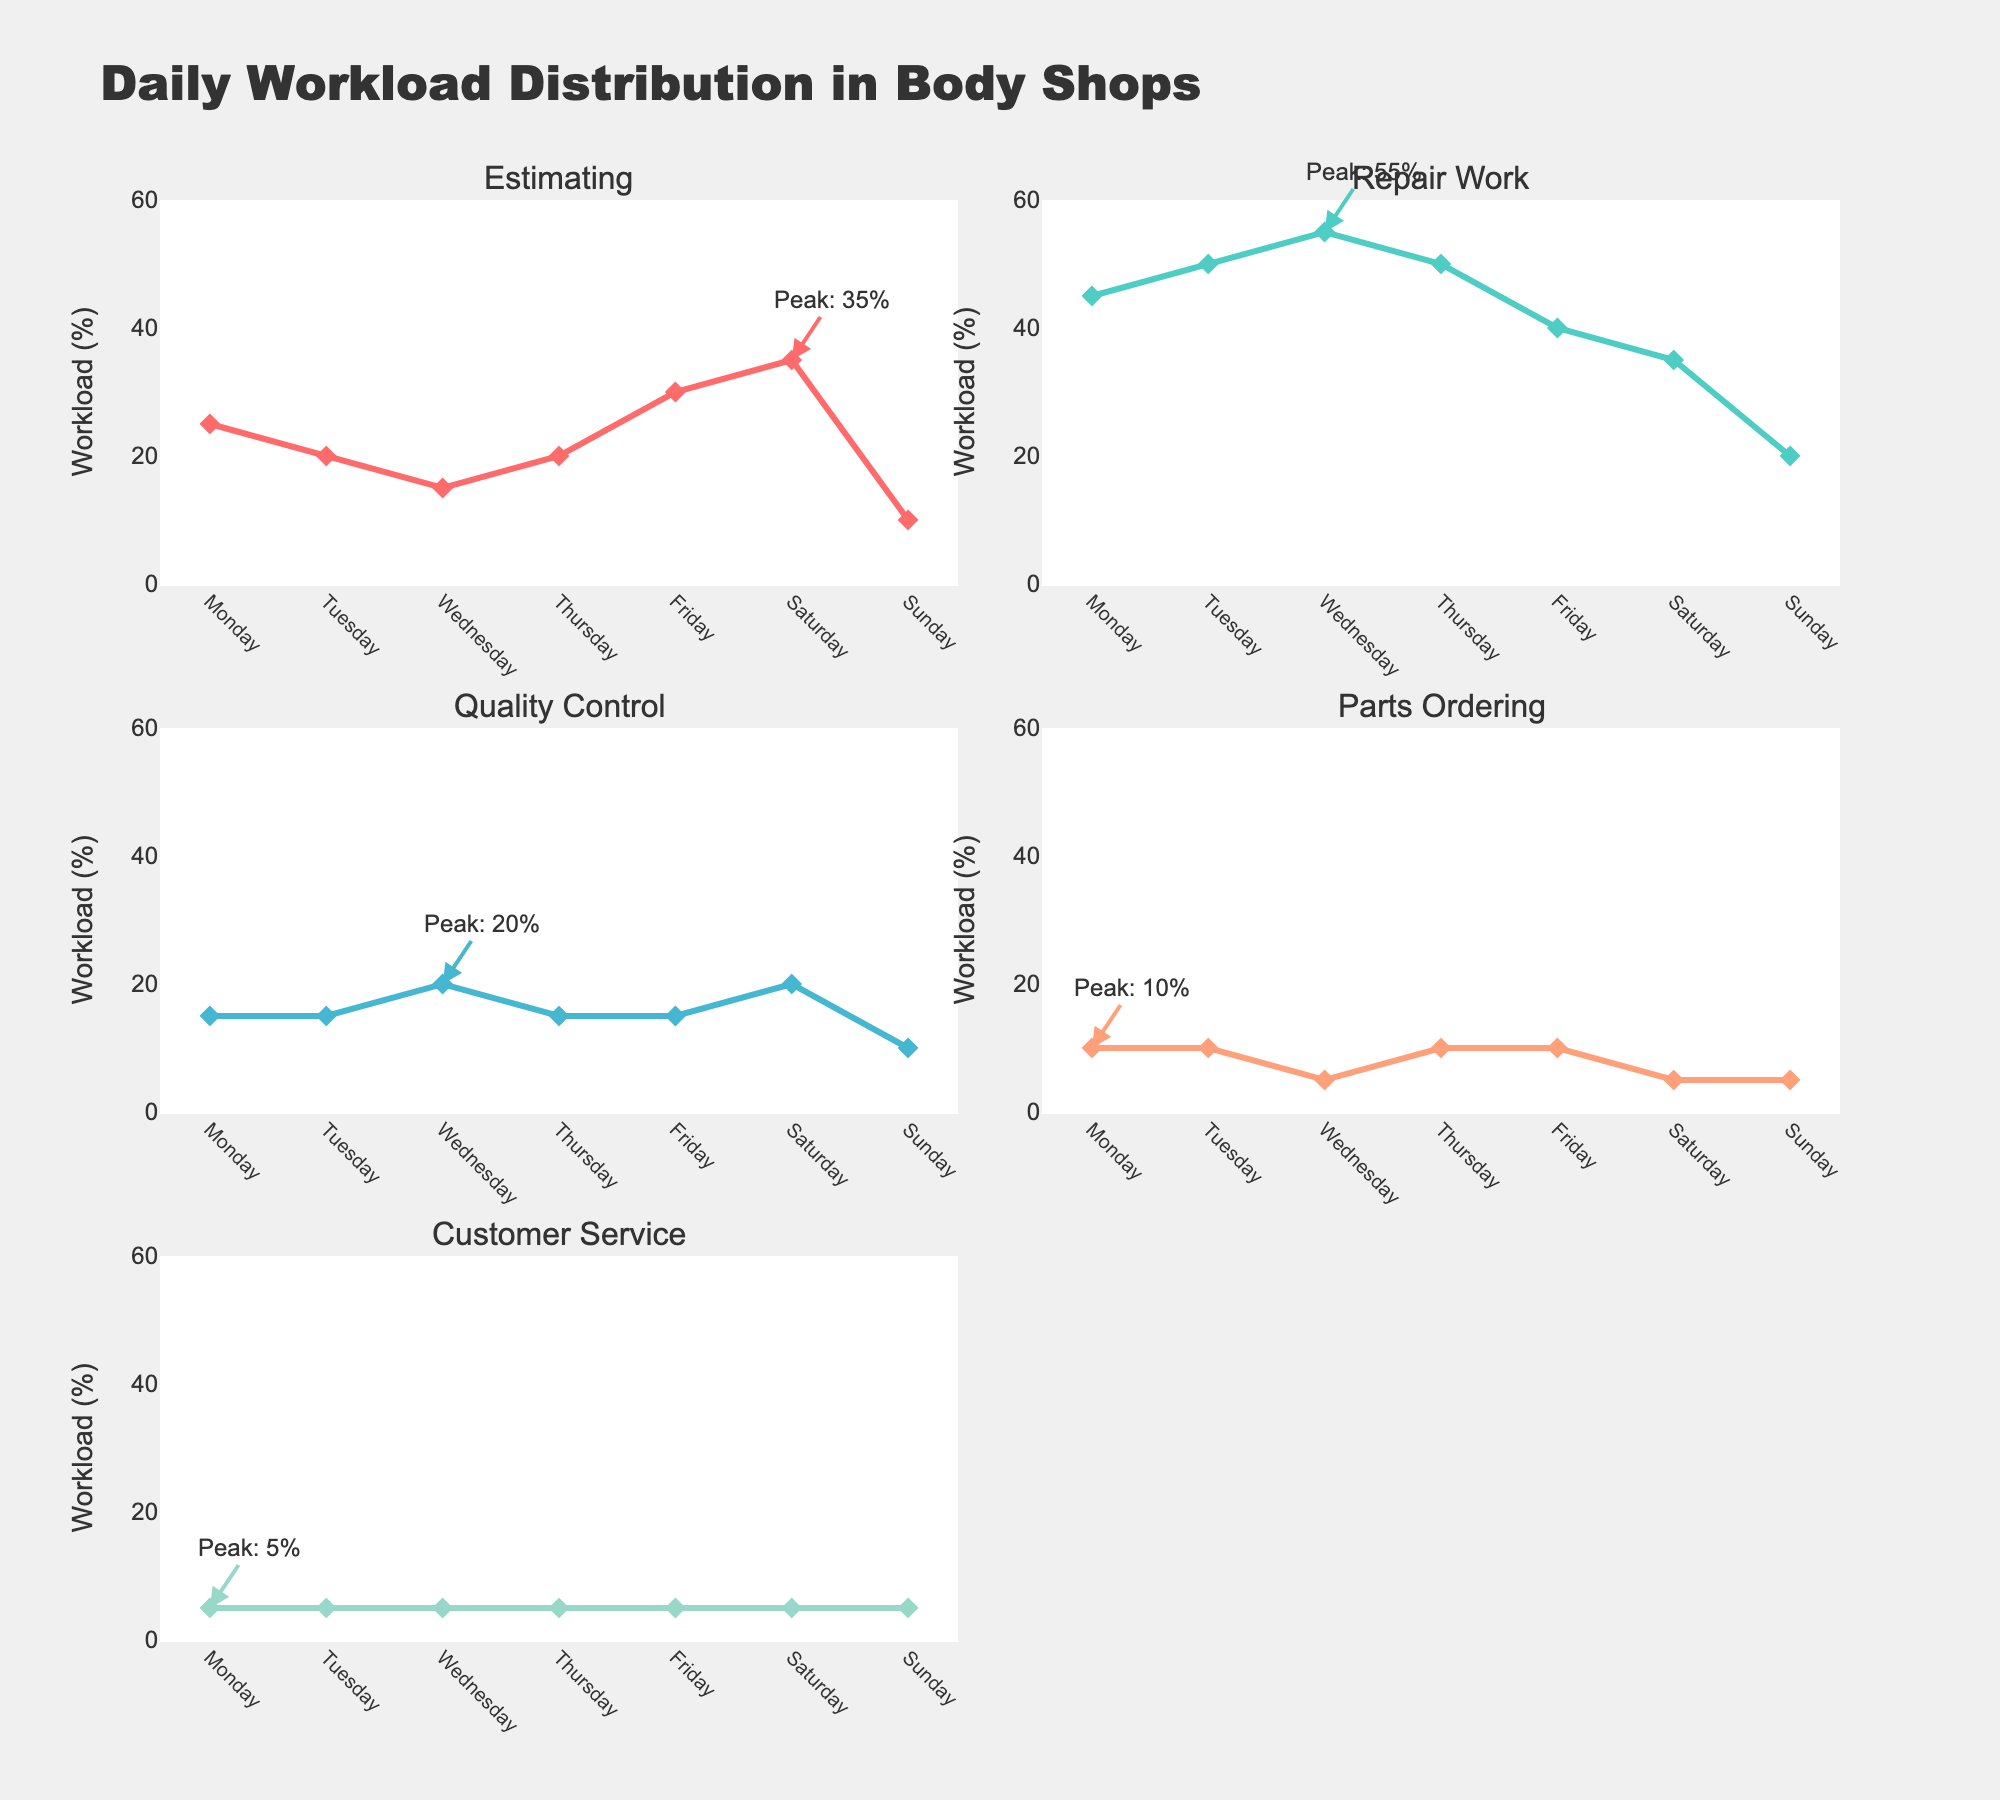Which task has the peak workload on Monday? The plot shows the peak workload for each task with annotations. For Monday, the highest peak annotation shows Repair Work with 45%.
Answer: Repair Work What is the average workload for Quality Control from Monday to Sunday? The Quality Control values for the week are 15, 15, 20, 15, 15, 20, 10. Adding these values gives 110. Dividing by 7 (number of days) results in an average of 110/7 ≈ 15.71.
Answer: ~15.71 Which day has the lowest workload for Estimating? Examining the Estimating subplot across the days, Sunday has the lowest workload with 10%.
Answer: Sunday Is the workload for Repair Work consistent throughout the week? Looking at the Repair Work subplot, the workload fluctuates between a minimum of 20% (Sunday) and a maximum of 55% (Wednesday), showing variability rather than consistency.
Answer: No How does Parts Ordering workload on Wednesday compare to that on Friday? From the Parts Ordering subplot, Wednesday has 5% and Friday also has 10%, making them equal.
Answer: Equal What is the total workload percentage for Customer Service over the week? Summing Customer Service percentages for each day: 5 + 5 + 5 + 5 + 5 + 5 + 5 = 35%.
Answer: 35% On which day does Estimating have its peak workload? From the annotations on the Estimating subplot, the peak workload is on Saturday with 35%.
Answer: Saturday Which task type shows the most variability in its workload throughout the week? Repair Work varies from 20% to 55%, which is a 35% range. This is the highest range compared to other tasks.
Answer: Repair Work 